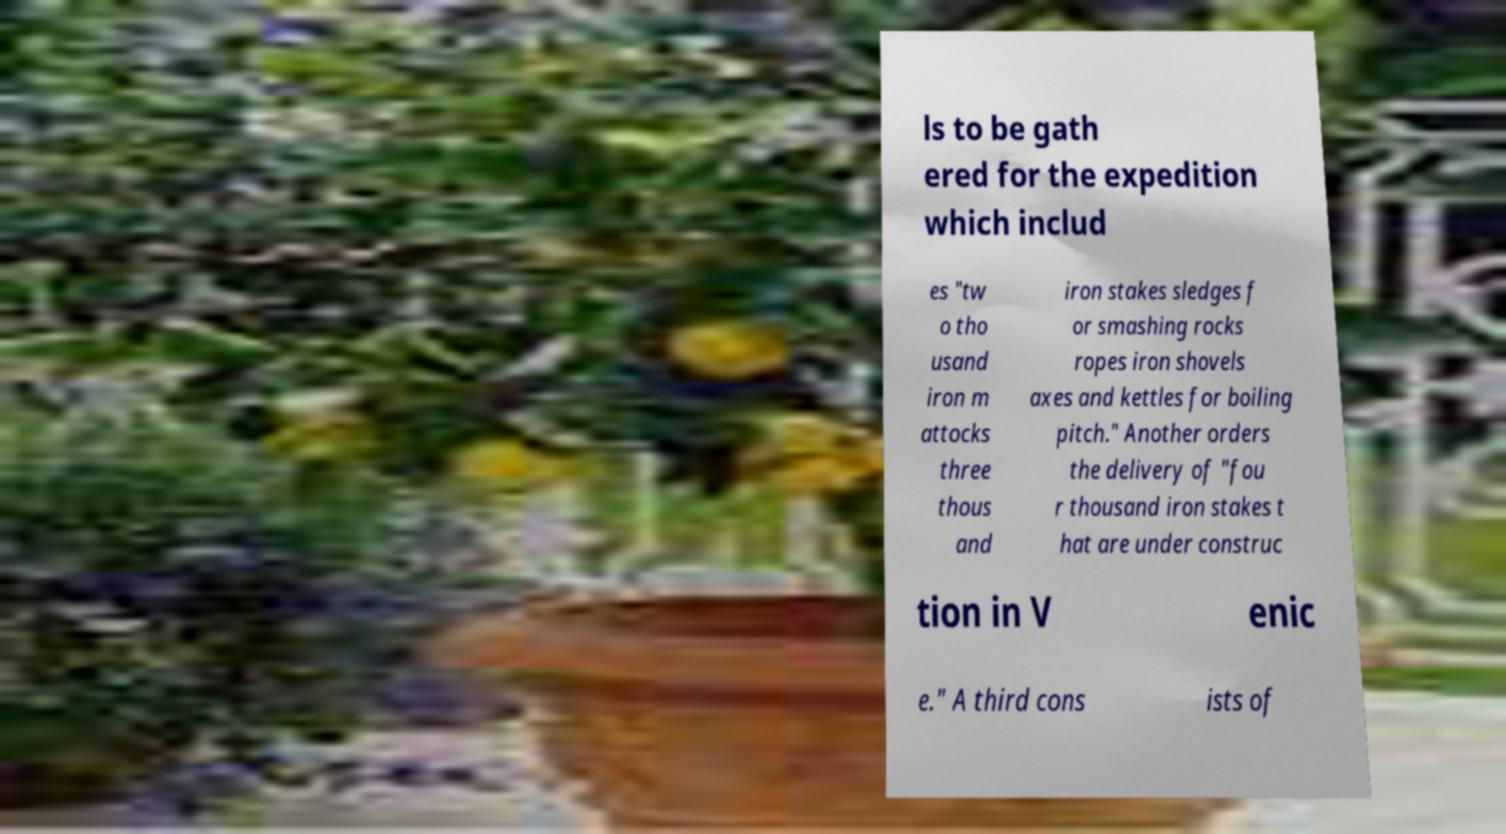Please read and relay the text visible in this image. What does it say? ls to be gath ered for the expedition which includ es "tw o tho usand iron m attocks three thous and iron stakes sledges f or smashing rocks ropes iron shovels axes and kettles for boiling pitch." Another orders the delivery of "fou r thousand iron stakes t hat are under construc tion in V enic e." A third cons ists of 